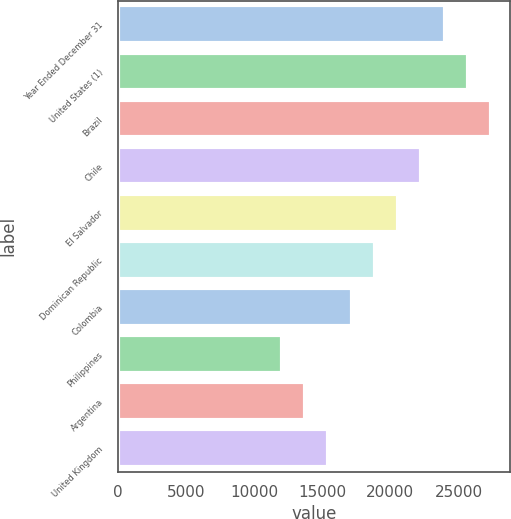Convert chart to OTSL. <chart><loc_0><loc_0><loc_500><loc_500><bar_chart><fcel>Year Ended December 31<fcel>United States (1)<fcel>Brazil<fcel>Chile<fcel>El Salvador<fcel>Dominican Republic<fcel>Colombia<fcel>Philippines<fcel>Argentina<fcel>United Kingdom<nl><fcel>23977.6<fcel>25685.5<fcel>27393.4<fcel>22269.7<fcel>20561.8<fcel>18853.9<fcel>17146<fcel>12022.3<fcel>13730.2<fcel>15438.1<nl></chart> 